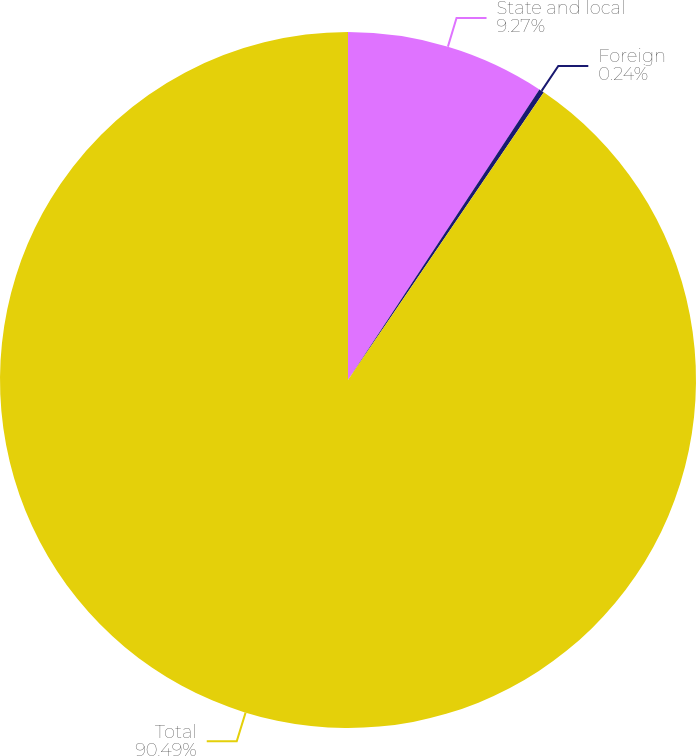Convert chart to OTSL. <chart><loc_0><loc_0><loc_500><loc_500><pie_chart><fcel>State and local<fcel>Foreign<fcel>Total<nl><fcel>9.27%<fcel>0.24%<fcel>90.49%<nl></chart> 